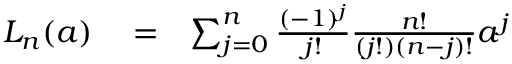Convert formula to latex. <formula><loc_0><loc_0><loc_500><loc_500>\begin{array} { r l r } { L _ { n } ( a ) } & = } & { \sum _ { j = 0 } ^ { n } \frac { ( - 1 ) ^ { j } } { j ! } \frac { n ! } { ( j ! ) ( n - j ) ! } a ^ { j } } \end{array}</formula> 